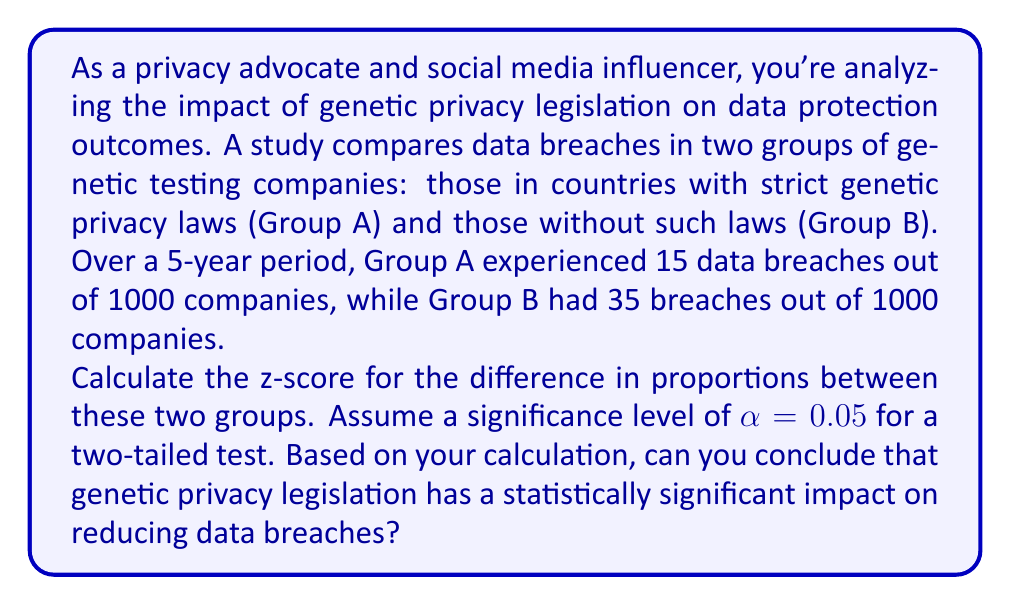Help me with this question. To determine if there's a statistically significant difference between the two groups, we'll use a two-proportion z-test. Let's break this down step-by-step:

1. Define our hypotheses:
   $H_0: p_A = p_B$ (null hypothesis)
   $H_a: p_A \neq p_B$ (alternative hypothesis)

2. Calculate the sample proportions:
   $\hat{p}_A = \frac{15}{1000} = 0.015$
   $\hat{p}_B = \frac{35}{1000} = 0.035$

3. Calculate the pooled sample proportion:
   $$\hat{p} = \frac{X_A + X_B}{n_A + n_B} = \frac{15 + 35}{1000 + 1000} = \frac{50}{2000} = 0.025$$

4. Calculate the standard error of the difference in proportions:
   $$SE = \sqrt{\hat{p}(1-\hat{p})(\frac{1}{n_A} + \frac{1}{n_B})}$$
   $$SE = \sqrt{0.025(1-0.025)(\frac{1}{1000} + \frac{1}{1000})} = \sqrt{0.024375 \cdot 0.002} = 0.00697$$

5. Calculate the z-score:
   $$z = \frac{\hat{p}_A - \hat{p}_B}{SE} = \frac{0.015 - 0.035}{0.00697} = -2.87$$

6. Determine the critical value:
   For a two-tailed test with α = 0.05, the critical z-value is ±1.96.

7. Make a decision:
   Since |-2.87| > 1.96, we reject the null hypothesis.

Therefore, we can conclude that there is a statistically significant difference between the two groups, suggesting that genetic privacy legislation has a significant impact on reducing data breaches.
Answer: The z-score is -2.87. Since |-2.87| > 1.96 (the critical value for α = 0.05), we reject the null hypothesis and conclude that genetic privacy legislation has a statistically significant impact on reducing data breaches. 